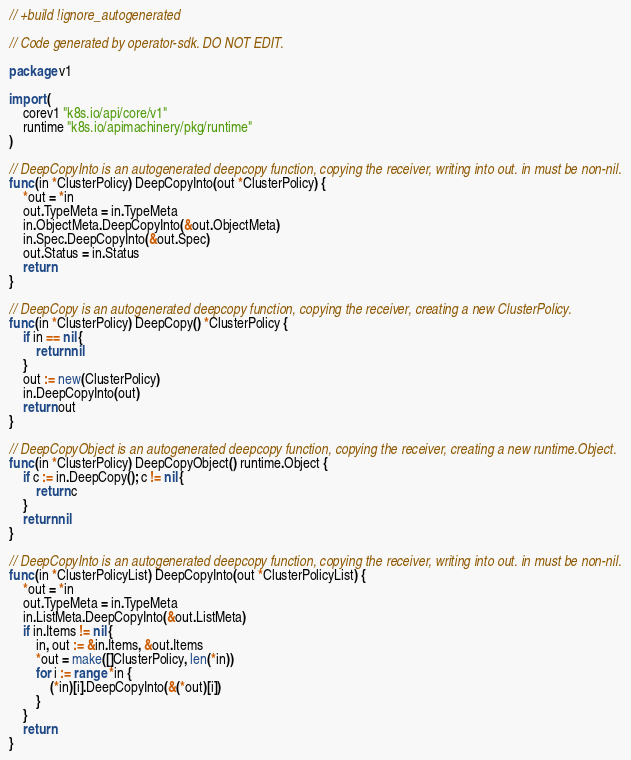Convert code to text. <code><loc_0><loc_0><loc_500><loc_500><_Go_>// +build !ignore_autogenerated

// Code generated by operator-sdk. DO NOT EDIT.

package v1

import (
	corev1 "k8s.io/api/core/v1"
	runtime "k8s.io/apimachinery/pkg/runtime"
)

// DeepCopyInto is an autogenerated deepcopy function, copying the receiver, writing into out. in must be non-nil.
func (in *ClusterPolicy) DeepCopyInto(out *ClusterPolicy) {
	*out = *in
	out.TypeMeta = in.TypeMeta
	in.ObjectMeta.DeepCopyInto(&out.ObjectMeta)
	in.Spec.DeepCopyInto(&out.Spec)
	out.Status = in.Status
	return
}

// DeepCopy is an autogenerated deepcopy function, copying the receiver, creating a new ClusterPolicy.
func (in *ClusterPolicy) DeepCopy() *ClusterPolicy {
	if in == nil {
		return nil
	}
	out := new(ClusterPolicy)
	in.DeepCopyInto(out)
	return out
}

// DeepCopyObject is an autogenerated deepcopy function, copying the receiver, creating a new runtime.Object.
func (in *ClusterPolicy) DeepCopyObject() runtime.Object {
	if c := in.DeepCopy(); c != nil {
		return c
	}
	return nil
}

// DeepCopyInto is an autogenerated deepcopy function, copying the receiver, writing into out. in must be non-nil.
func (in *ClusterPolicyList) DeepCopyInto(out *ClusterPolicyList) {
	*out = *in
	out.TypeMeta = in.TypeMeta
	in.ListMeta.DeepCopyInto(&out.ListMeta)
	if in.Items != nil {
		in, out := &in.Items, &out.Items
		*out = make([]ClusterPolicy, len(*in))
		for i := range *in {
			(*in)[i].DeepCopyInto(&(*out)[i])
		}
	}
	return
}
</code> 